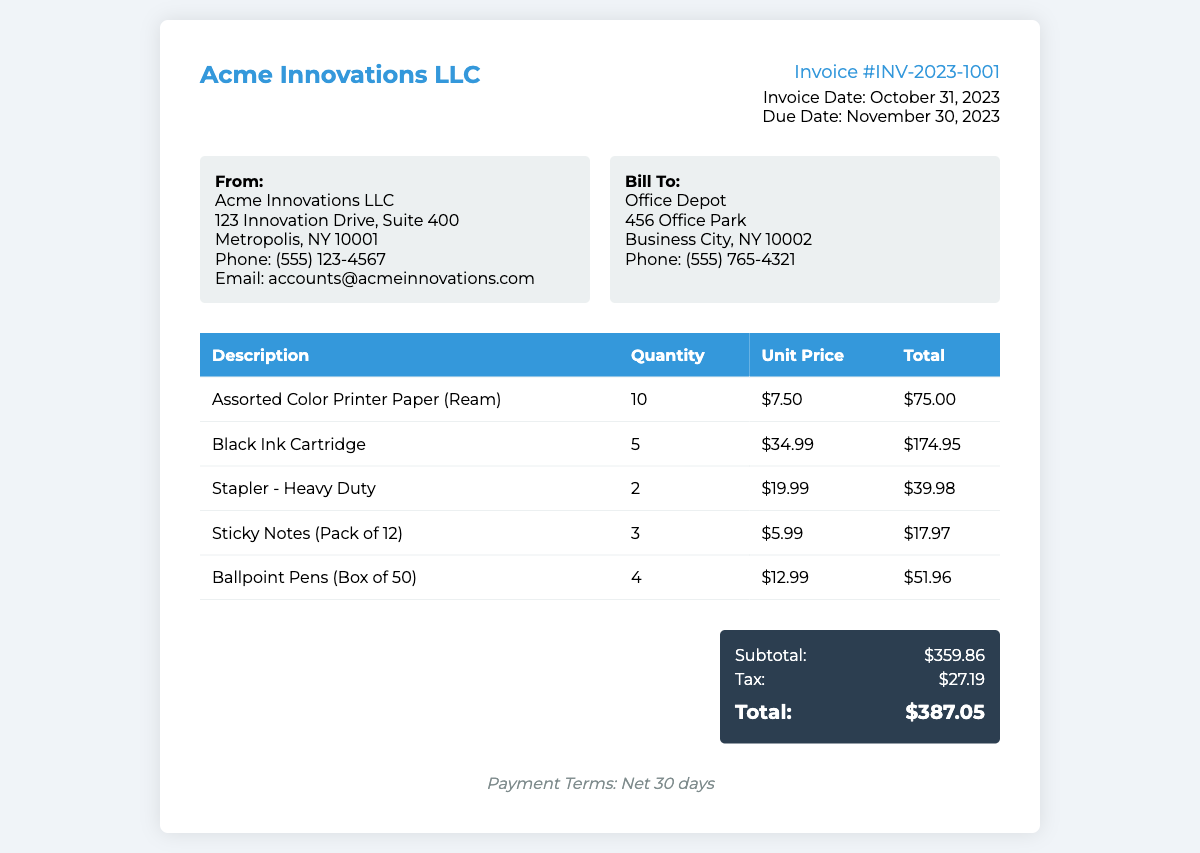What is the invoice number? The invoice number is listed prominently in the document as part of the invoice details.
Answer: INV-2023-1001 What is the total amount due? The total amount is the final figure listed in the total section of the document, encompassing the subtotal and tax.
Answer: $387.05 What is the bill-to company name? The name of the company being billed is given in the billing section of the document.
Answer: Office Depot How many Black Ink Cartridges were purchased? The quantity of Black Ink Cartridges is mentioned in the itemized list of the invoice.
Answer: 5 What is the subtotal before tax? The subtotal is the total amount before adding the tax, found in the total section of the document.
Answer: $359.86 What is the due date for payment? The due date is specified in the invoice details section of the document.
Answer: November 30, 2023 How many items were purchased in total? To determine the total number of items, sum the quantities of each line item in the invoice.
Answer: 24 What is the unit price of the Assorted Color Printer Paper? The unit price is shown clearly next to the item description in the invoice table.
Answer: $7.50 What are the payment terms specified in the document? The payment terms are stated at the bottom of the invoice, indicating when payment is expected.
Answer: Net 30 days 